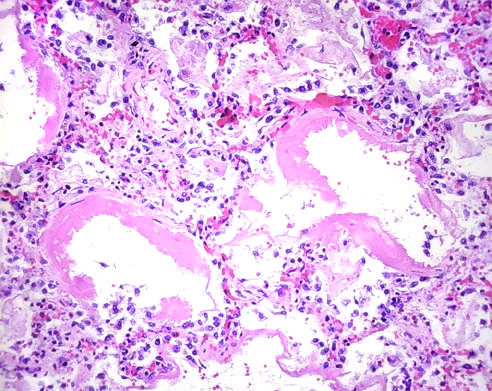re some alveoli collapsed, while others are distended?
Answer the question using a single word or phrase. Yes 